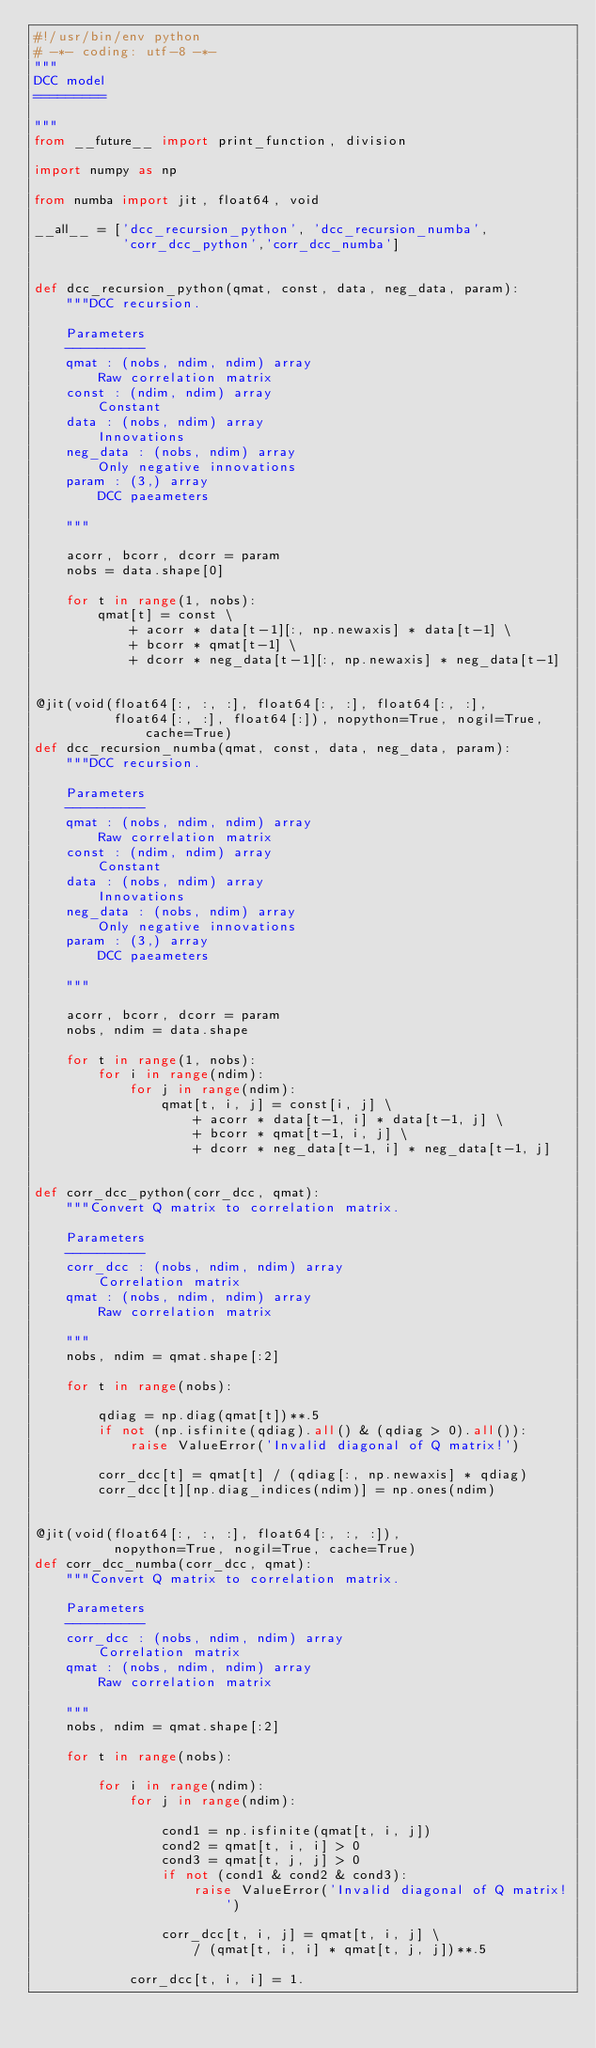<code> <loc_0><loc_0><loc_500><loc_500><_Python_>#!/usr/bin/env python
# -*- coding: utf-8 -*-
"""
DCC model
=========

"""
from __future__ import print_function, division

import numpy as np

from numba import jit, float64, void

__all__ = ['dcc_recursion_python', 'dcc_recursion_numba',
           'corr_dcc_python','corr_dcc_numba']


def dcc_recursion_python(qmat, const, data, neg_data, param):
    """DCC recursion.

    Parameters
    ----------
    qmat : (nobs, ndim, ndim) array
        Raw correlation matrix
    const : (ndim, ndim) array
        Constant
    data : (nobs, ndim) array
        Innovations
    neg_data : (nobs, ndim) array
        Only negative innovations
    param : (3,) array
        DCC paeameters

    """

    acorr, bcorr, dcorr = param
    nobs = data.shape[0]

    for t in range(1, nobs):
        qmat[t] = const \
            + acorr * data[t-1][:, np.newaxis] * data[t-1] \
            + bcorr * qmat[t-1] \
            + dcorr * neg_data[t-1][:, np.newaxis] * neg_data[t-1]


@jit(void(float64[:, :, :], float64[:, :], float64[:, :],
          float64[:, :], float64[:]), nopython=True, nogil=True, cache=True)
def dcc_recursion_numba(qmat, const, data, neg_data, param):
    """DCC recursion.

    Parameters
    ----------
    qmat : (nobs, ndim, ndim) array
        Raw correlation matrix
    const : (ndim, ndim) array
        Constant
    data : (nobs, ndim) array
        Innovations
    neg_data : (nobs, ndim) array
        Only negative innovations
    param : (3,) array
        DCC paeameters

    """

    acorr, bcorr, dcorr = param
    nobs, ndim = data.shape

    for t in range(1, nobs):
        for i in range(ndim):
            for j in range(ndim):
                qmat[t, i, j] = const[i, j] \
                    + acorr * data[t-1, i] * data[t-1, j] \
                    + bcorr * qmat[t-1, i, j] \
                    + dcorr * neg_data[t-1, i] * neg_data[t-1, j]


def corr_dcc_python(corr_dcc, qmat):
    """Convert Q matrix to correlation matrix.

    Parameters
    ----------
    corr_dcc : (nobs, ndim, ndim) array
        Correlation matrix
    qmat : (nobs, ndim, ndim) array
        Raw correlation matrix

    """
    nobs, ndim = qmat.shape[:2]

    for t in range(nobs):

        qdiag = np.diag(qmat[t])**.5
        if not (np.isfinite(qdiag).all() & (qdiag > 0).all()):
            raise ValueError('Invalid diagonal of Q matrix!')

        corr_dcc[t] = qmat[t] / (qdiag[:, np.newaxis] * qdiag)
        corr_dcc[t][np.diag_indices(ndim)] = np.ones(ndim)


@jit(void(float64[:, :, :], float64[:, :, :]),
          nopython=True, nogil=True, cache=True)
def corr_dcc_numba(corr_dcc, qmat):
    """Convert Q matrix to correlation matrix.

    Parameters
    ----------
    corr_dcc : (nobs, ndim, ndim) array
        Correlation matrix
    qmat : (nobs, ndim, ndim) array
        Raw correlation matrix

    """
    nobs, ndim = qmat.shape[:2]

    for t in range(nobs):

        for i in range(ndim):
            for j in range(ndim):

                cond1 = np.isfinite(qmat[t, i, j])
                cond2 = qmat[t, i, i] > 0
                cond3 = qmat[t, j, j] > 0
                if not (cond1 & cond2 & cond3):
                    raise ValueError('Invalid diagonal of Q matrix!')

                corr_dcc[t, i, j] = qmat[t, i, j] \
                    / (qmat[t, i, i] * qmat[t, j, j])**.5

            corr_dcc[t, i, i] = 1.
</code> 